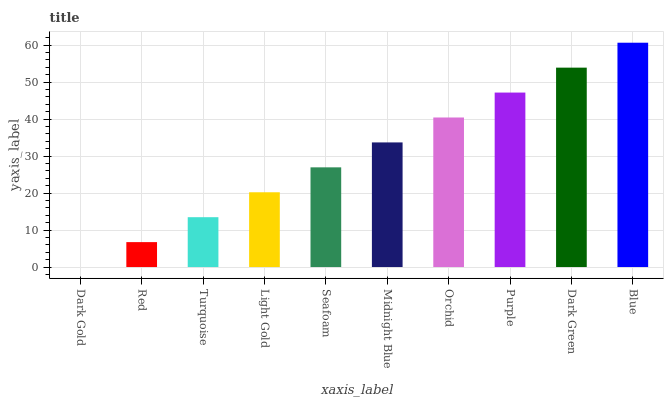Is Red the minimum?
Answer yes or no. No. Is Red the maximum?
Answer yes or no. No. Is Red greater than Dark Gold?
Answer yes or no. Yes. Is Dark Gold less than Red?
Answer yes or no. Yes. Is Dark Gold greater than Red?
Answer yes or no. No. Is Red less than Dark Gold?
Answer yes or no. No. Is Midnight Blue the high median?
Answer yes or no. Yes. Is Seafoam the low median?
Answer yes or no. Yes. Is Blue the high median?
Answer yes or no. No. Is Blue the low median?
Answer yes or no. No. 